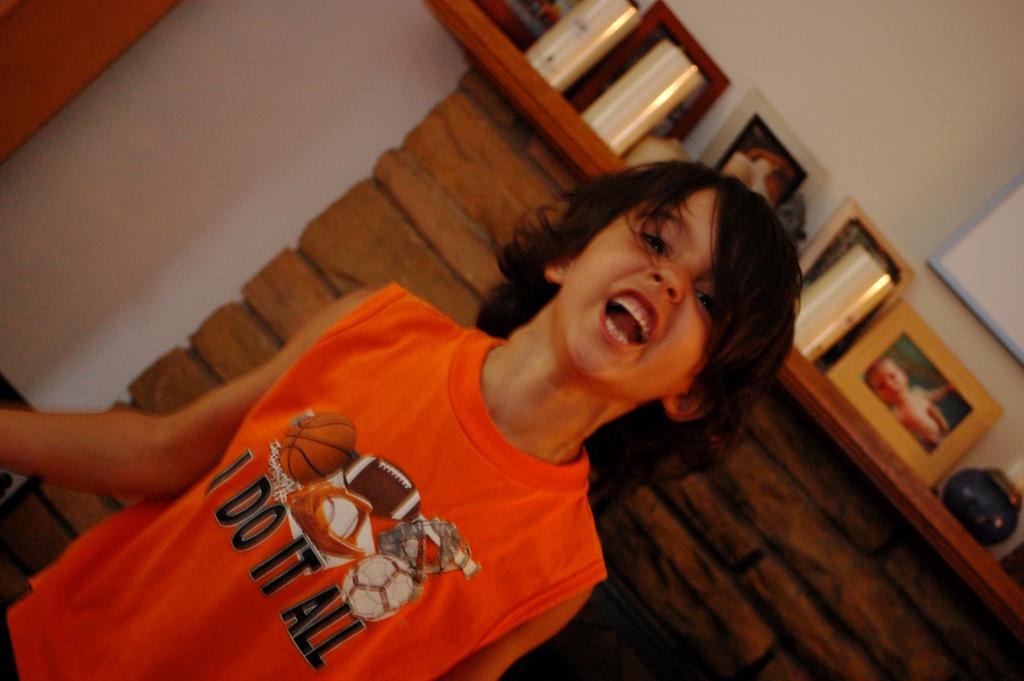Which sports does this boy claim to do?
Your answer should be very brief. All. Does the boy play hockey according to his shirt?
Your answer should be compact. Yes. 